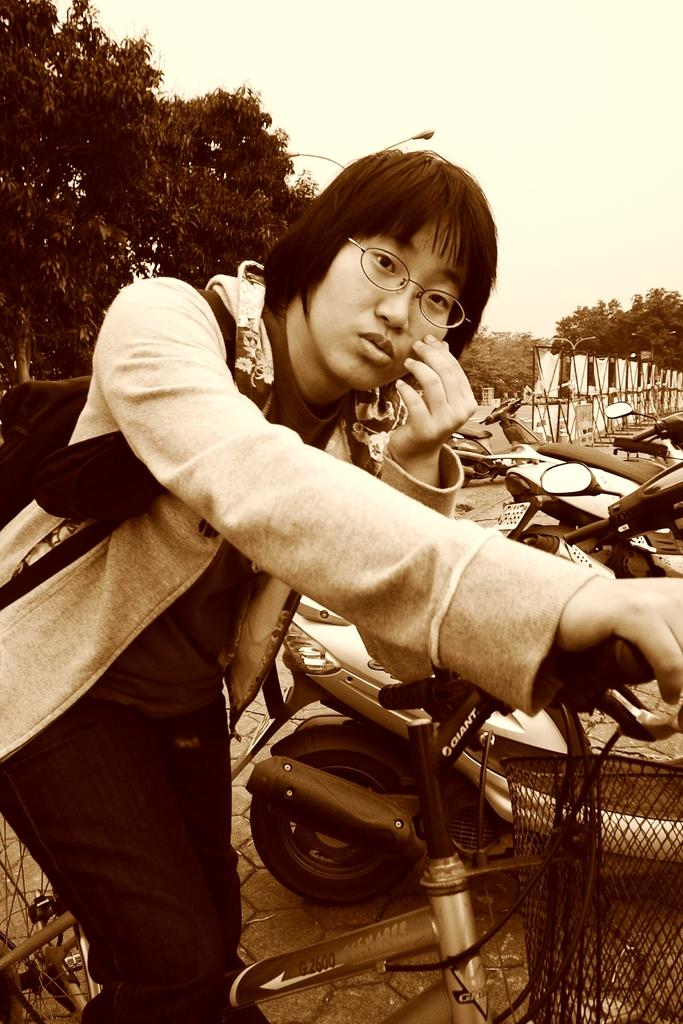What is the main subject of the image? There is a person in the image. What is the person doing in the image? The person is sitting on a bicycle. What can be seen in the background of the image? There are trees visible in the image. What color scheme is used in the image? The image is in black and white color. What type of mouthwash is visible in the image? There is no mouthwash present in the image. What happened to the bedroom after the incident in the image? There is no bedroom or incident mentioned in the image, so we cannot discuss the aftermath. 